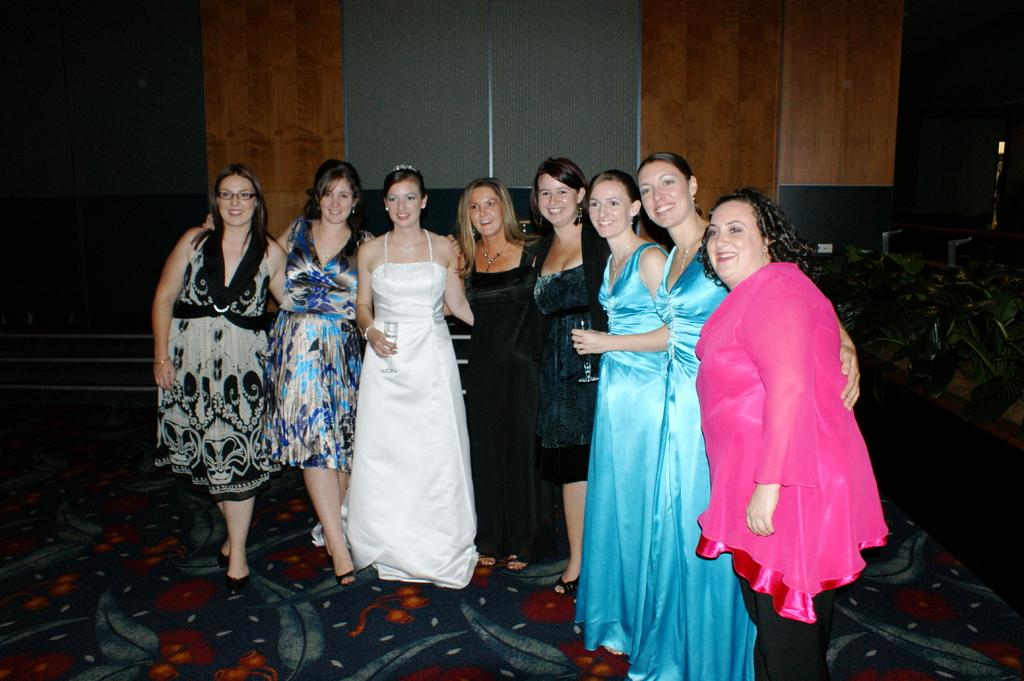What are the people in the image doing? The people in the image are standing and smiling. What can be seen in the background of the image? There is a wall in the background of the image. What type of vegetation is on the right side of the image? There are plants on the right side of the image. What type of country can be seen in the image? There is no country visible in the image; it features people standing and smiling with a wall and plants in the background. Can you tell me how many boats are docked in the harbor in the image? There is no harbor or boats present in the image. 